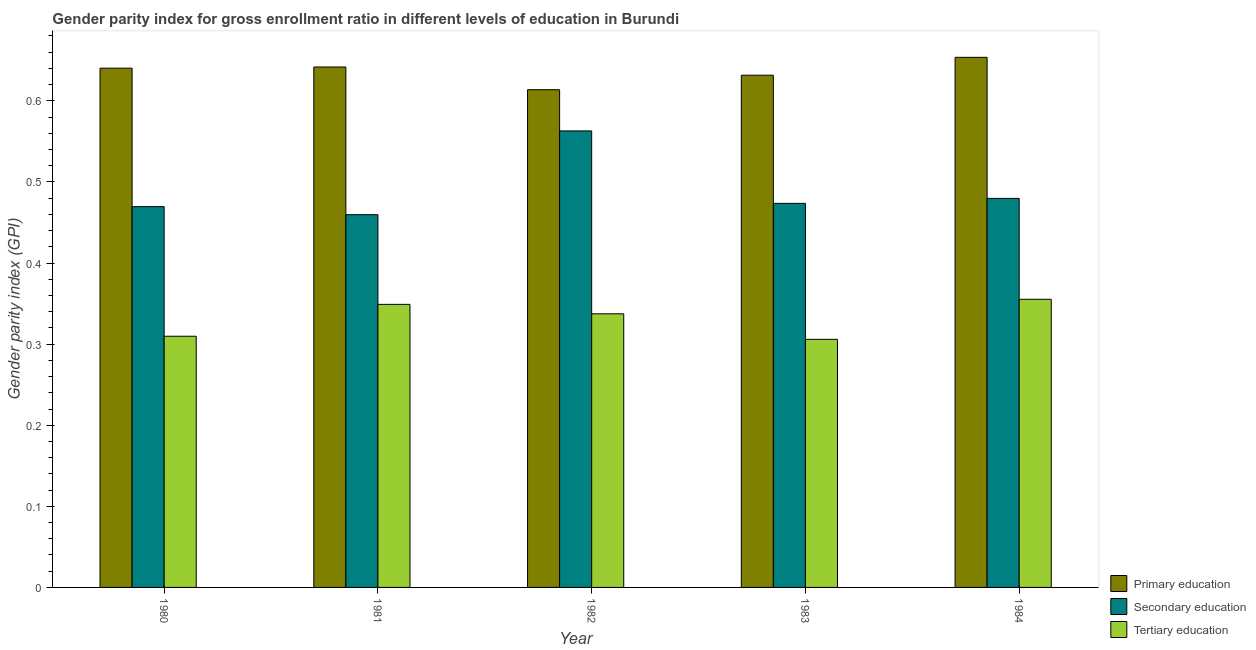How many bars are there on the 3rd tick from the left?
Ensure brevity in your answer.  3. What is the label of the 2nd group of bars from the left?
Offer a terse response. 1981. In how many cases, is the number of bars for a given year not equal to the number of legend labels?
Your response must be concise. 0. What is the gender parity index in tertiary education in 1981?
Your response must be concise. 0.35. Across all years, what is the maximum gender parity index in primary education?
Give a very brief answer. 0.65. Across all years, what is the minimum gender parity index in tertiary education?
Ensure brevity in your answer.  0.31. In which year was the gender parity index in tertiary education minimum?
Offer a very short reply. 1983. What is the total gender parity index in primary education in the graph?
Your answer should be compact. 3.18. What is the difference between the gender parity index in secondary education in 1981 and that in 1982?
Offer a very short reply. -0.1. What is the difference between the gender parity index in secondary education in 1982 and the gender parity index in tertiary education in 1984?
Offer a very short reply. 0.08. What is the average gender parity index in secondary education per year?
Make the answer very short. 0.49. In the year 1984, what is the difference between the gender parity index in primary education and gender parity index in secondary education?
Provide a short and direct response. 0. What is the ratio of the gender parity index in primary education in 1983 to that in 1984?
Make the answer very short. 0.97. Is the gender parity index in secondary education in 1980 less than that in 1982?
Provide a short and direct response. Yes. Is the difference between the gender parity index in tertiary education in 1982 and 1983 greater than the difference between the gender parity index in primary education in 1982 and 1983?
Ensure brevity in your answer.  No. What is the difference between the highest and the second highest gender parity index in tertiary education?
Offer a terse response. 0.01. What is the difference between the highest and the lowest gender parity index in tertiary education?
Ensure brevity in your answer.  0.05. In how many years, is the gender parity index in primary education greater than the average gender parity index in primary education taken over all years?
Your response must be concise. 3. Is the sum of the gender parity index in primary education in 1982 and 1983 greater than the maximum gender parity index in secondary education across all years?
Offer a very short reply. Yes. What does the 2nd bar from the left in 1984 represents?
Ensure brevity in your answer.  Secondary education. What does the 1st bar from the right in 1983 represents?
Your answer should be compact. Tertiary education. How many bars are there?
Give a very brief answer. 15. Are all the bars in the graph horizontal?
Provide a succinct answer. No. How many years are there in the graph?
Offer a very short reply. 5. Does the graph contain any zero values?
Your answer should be very brief. No. Does the graph contain grids?
Offer a very short reply. No. How are the legend labels stacked?
Keep it short and to the point. Vertical. What is the title of the graph?
Offer a terse response. Gender parity index for gross enrollment ratio in different levels of education in Burundi. Does "Interest" appear as one of the legend labels in the graph?
Make the answer very short. No. What is the label or title of the Y-axis?
Your response must be concise. Gender parity index (GPI). What is the Gender parity index (GPI) in Primary education in 1980?
Offer a terse response. 0.64. What is the Gender parity index (GPI) in Secondary education in 1980?
Ensure brevity in your answer.  0.47. What is the Gender parity index (GPI) in Tertiary education in 1980?
Give a very brief answer. 0.31. What is the Gender parity index (GPI) in Primary education in 1981?
Ensure brevity in your answer.  0.64. What is the Gender parity index (GPI) of Secondary education in 1981?
Keep it short and to the point. 0.46. What is the Gender parity index (GPI) in Tertiary education in 1981?
Make the answer very short. 0.35. What is the Gender parity index (GPI) of Primary education in 1982?
Your answer should be compact. 0.61. What is the Gender parity index (GPI) of Secondary education in 1982?
Provide a short and direct response. 0.56. What is the Gender parity index (GPI) in Tertiary education in 1982?
Provide a short and direct response. 0.34. What is the Gender parity index (GPI) of Primary education in 1983?
Your answer should be very brief. 0.63. What is the Gender parity index (GPI) of Secondary education in 1983?
Keep it short and to the point. 0.47. What is the Gender parity index (GPI) of Tertiary education in 1983?
Make the answer very short. 0.31. What is the Gender parity index (GPI) in Primary education in 1984?
Provide a short and direct response. 0.65. What is the Gender parity index (GPI) in Secondary education in 1984?
Provide a short and direct response. 0.48. What is the Gender parity index (GPI) of Tertiary education in 1984?
Your answer should be very brief. 0.36. Across all years, what is the maximum Gender parity index (GPI) of Primary education?
Your response must be concise. 0.65. Across all years, what is the maximum Gender parity index (GPI) of Secondary education?
Your answer should be compact. 0.56. Across all years, what is the maximum Gender parity index (GPI) in Tertiary education?
Make the answer very short. 0.36. Across all years, what is the minimum Gender parity index (GPI) in Primary education?
Ensure brevity in your answer.  0.61. Across all years, what is the minimum Gender parity index (GPI) in Secondary education?
Keep it short and to the point. 0.46. Across all years, what is the minimum Gender parity index (GPI) of Tertiary education?
Give a very brief answer. 0.31. What is the total Gender parity index (GPI) of Primary education in the graph?
Provide a succinct answer. 3.18. What is the total Gender parity index (GPI) in Secondary education in the graph?
Ensure brevity in your answer.  2.45. What is the total Gender parity index (GPI) in Tertiary education in the graph?
Your answer should be very brief. 1.66. What is the difference between the Gender parity index (GPI) in Primary education in 1980 and that in 1981?
Your response must be concise. -0. What is the difference between the Gender parity index (GPI) in Secondary education in 1980 and that in 1981?
Offer a very short reply. 0.01. What is the difference between the Gender parity index (GPI) of Tertiary education in 1980 and that in 1981?
Keep it short and to the point. -0.04. What is the difference between the Gender parity index (GPI) of Primary education in 1980 and that in 1982?
Your answer should be very brief. 0.03. What is the difference between the Gender parity index (GPI) in Secondary education in 1980 and that in 1982?
Keep it short and to the point. -0.09. What is the difference between the Gender parity index (GPI) in Tertiary education in 1980 and that in 1982?
Ensure brevity in your answer.  -0.03. What is the difference between the Gender parity index (GPI) of Primary education in 1980 and that in 1983?
Offer a terse response. 0.01. What is the difference between the Gender parity index (GPI) in Secondary education in 1980 and that in 1983?
Ensure brevity in your answer.  -0. What is the difference between the Gender parity index (GPI) in Tertiary education in 1980 and that in 1983?
Your answer should be very brief. 0. What is the difference between the Gender parity index (GPI) of Primary education in 1980 and that in 1984?
Your response must be concise. -0.01. What is the difference between the Gender parity index (GPI) in Secondary education in 1980 and that in 1984?
Keep it short and to the point. -0.01. What is the difference between the Gender parity index (GPI) in Tertiary education in 1980 and that in 1984?
Your response must be concise. -0.05. What is the difference between the Gender parity index (GPI) in Primary education in 1981 and that in 1982?
Provide a succinct answer. 0.03. What is the difference between the Gender parity index (GPI) in Secondary education in 1981 and that in 1982?
Make the answer very short. -0.1. What is the difference between the Gender parity index (GPI) of Tertiary education in 1981 and that in 1982?
Ensure brevity in your answer.  0.01. What is the difference between the Gender parity index (GPI) in Primary education in 1981 and that in 1983?
Offer a very short reply. 0.01. What is the difference between the Gender parity index (GPI) in Secondary education in 1981 and that in 1983?
Offer a very short reply. -0.01. What is the difference between the Gender parity index (GPI) in Tertiary education in 1981 and that in 1983?
Keep it short and to the point. 0.04. What is the difference between the Gender parity index (GPI) in Primary education in 1981 and that in 1984?
Your answer should be very brief. -0.01. What is the difference between the Gender parity index (GPI) in Secondary education in 1981 and that in 1984?
Ensure brevity in your answer.  -0.02. What is the difference between the Gender parity index (GPI) in Tertiary education in 1981 and that in 1984?
Make the answer very short. -0.01. What is the difference between the Gender parity index (GPI) of Primary education in 1982 and that in 1983?
Your response must be concise. -0.02. What is the difference between the Gender parity index (GPI) of Secondary education in 1982 and that in 1983?
Your answer should be very brief. 0.09. What is the difference between the Gender parity index (GPI) of Tertiary education in 1982 and that in 1983?
Your answer should be very brief. 0.03. What is the difference between the Gender parity index (GPI) of Primary education in 1982 and that in 1984?
Your answer should be very brief. -0.04. What is the difference between the Gender parity index (GPI) of Secondary education in 1982 and that in 1984?
Offer a very short reply. 0.08. What is the difference between the Gender parity index (GPI) of Tertiary education in 1982 and that in 1984?
Your answer should be very brief. -0.02. What is the difference between the Gender parity index (GPI) in Primary education in 1983 and that in 1984?
Make the answer very short. -0.02. What is the difference between the Gender parity index (GPI) in Secondary education in 1983 and that in 1984?
Offer a very short reply. -0.01. What is the difference between the Gender parity index (GPI) of Tertiary education in 1983 and that in 1984?
Your answer should be very brief. -0.05. What is the difference between the Gender parity index (GPI) in Primary education in 1980 and the Gender parity index (GPI) in Secondary education in 1981?
Provide a short and direct response. 0.18. What is the difference between the Gender parity index (GPI) in Primary education in 1980 and the Gender parity index (GPI) in Tertiary education in 1981?
Give a very brief answer. 0.29. What is the difference between the Gender parity index (GPI) in Secondary education in 1980 and the Gender parity index (GPI) in Tertiary education in 1981?
Keep it short and to the point. 0.12. What is the difference between the Gender parity index (GPI) in Primary education in 1980 and the Gender parity index (GPI) in Secondary education in 1982?
Ensure brevity in your answer.  0.08. What is the difference between the Gender parity index (GPI) in Primary education in 1980 and the Gender parity index (GPI) in Tertiary education in 1982?
Provide a succinct answer. 0.3. What is the difference between the Gender parity index (GPI) in Secondary education in 1980 and the Gender parity index (GPI) in Tertiary education in 1982?
Ensure brevity in your answer.  0.13. What is the difference between the Gender parity index (GPI) of Primary education in 1980 and the Gender parity index (GPI) of Secondary education in 1983?
Provide a succinct answer. 0.17. What is the difference between the Gender parity index (GPI) in Primary education in 1980 and the Gender parity index (GPI) in Tertiary education in 1983?
Provide a short and direct response. 0.33. What is the difference between the Gender parity index (GPI) of Secondary education in 1980 and the Gender parity index (GPI) of Tertiary education in 1983?
Your answer should be compact. 0.16. What is the difference between the Gender parity index (GPI) of Primary education in 1980 and the Gender parity index (GPI) of Secondary education in 1984?
Give a very brief answer. 0.16. What is the difference between the Gender parity index (GPI) of Primary education in 1980 and the Gender parity index (GPI) of Tertiary education in 1984?
Provide a succinct answer. 0.28. What is the difference between the Gender parity index (GPI) of Secondary education in 1980 and the Gender parity index (GPI) of Tertiary education in 1984?
Ensure brevity in your answer.  0.11. What is the difference between the Gender parity index (GPI) of Primary education in 1981 and the Gender parity index (GPI) of Secondary education in 1982?
Provide a succinct answer. 0.08. What is the difference between the Gender parity index (GPI) in Primary education in 1981 and the Gender parity index (GPI) in Tertiary education in 1982?
Your response must be concise. 0.3. What is the difference between the Gender parity index (GPI) of Secondary education in 1981 and the Gender parity index (GPI) of Tertiary education in 1982?
Give a very brief answer. 0.12. What is the difference between the Gender parity index (GPI) in Primary education in 1981 and the Gender parity index (GPI) in Secondary education in 1983?
Offer a terse response. 0.17. What is the difference between the Gender parity index (GPI) of Primary education in 1981 and the Gender parity index (GPI) of Tertiary education in 1983?
Ensure brevity in your answer.  0.34. What is the difference between the Gender parity index (GPI) in Secondary education in 1981 and the Gender parity index (GPI) in Tertiary education in 1983?
Ensure brevity in your answer.  0.15. What is the difference between the Gender parity index (GPI) in Primary education in 1981 and the Gender parity index (GPI) in Secondary education in 1984?
Offer a terse response. 0.16. What is the difference between the Gender parity index (GPI) in Primary education in 1981 and the Gender parity index (GPI) in Tertiary education in 1984?
Your answer should be very brief. 0.29. What is the difference between the Gender parity index (GPI) of Secondary education in 1981 and the Gender parity index (GPI) of Tertiary education in 1984?
Provide a short and direct response. 0.1. What is the difference between the Gender parity index (GPI) of Primary education in 1982 and the Gender parity index (GPI) of Secondary education in 1983?
Provide a short and direct response. 0.14. What is the difference between the Gender parity index (GPI) in Primary education in 1982 and the Gender parity index (GPI) in Tertiary education in 1983?
Ensure brevity in your answer.  0.31. What is the difference between the Gender parity index (GPI) of Secondary education in 1982 and the Gender parity index (GPI) of Tertiary education in 1983?
Provide a succinct answer. 0.26. What is the difference between the Gender parity index (GPI) of Primary education in 1982 and the Gender parity index (GPI) of Secondary education in 1984?
Your answer should be compact. 0.13. What is the difference between the Gender parity index (GPI) of Primary education in 1982 and the Gender parity index (GPI) of Tertiary education in 1984?
Offer a terse response. 0.26. What is the difference between the Gender parity index (GPI) in Secondary education in 1982 and the Gender parity index (GPI) in Tertiary education in 1984?
Your answer should be compact. 0.21. What is the difference between the Gender parity index (GPI) of Primary education in 1983 and the Gender parity index (GPI) of Secondary education in 1984?
Your response must be concise. 0.15. What is the difference between the Gender parity index (GPI) in Primary education in 1983 and the Gender parity index (GPI) in Tertiary education in 1984?
Offer a terse response. 0.28. What is the difference between the Gender parity index (GPI) of Secondary education in 1983 and the Gender parity index (GPI) of Tertiary education in 1984?
Give a very brief answer. 0.12. What is the average Gender parity index (GPI) in Primary education per year?
Ensure brevity in your answer.  0.64. What is the average Gender parity index (GPI) in Secondary education per year?
Your answer should be very brief. 0.49. What is the average Gender parity index (GPI) in Tertiary education per year?
Give a very brief answer. 0.33. In the year 1980, what is the difference between the Gender parity index (GPI) of Primary education and Gender parity index (GPI) of Secondary education?
Provide a succinct answer. 0.17. In the year 1980, what is the difference between the Gender parity index (GPI) of Primary education and Gender parity index (GPI) of Tertiary education?
Ensure brevity in your answer.  0.33. In the year 1980, what is the difference between the Gender parity index (GPI) of Secondary education and Gender parity index (GPI) of Tertiary education?
Ensure brevity in your answer.  0.16. In the year 1981, what is the difference between the Gender parity index (GPI) in Primary education and Gender parity index (GPI) in Secondary education?
Give a very brief answer. 0.18. In the year 1981, what is the difference between the Gender parity index (GPI) in Primary education and Gender parity index (GPI) in Tertiary education?
Offer a terse response. 0.29. In the year 1981, what is the difference between the Gender parity index (GPI) in Secondary education and Gender parity index (GPI) in Tertiary education?
Make the answer very short. 0.11. In the year 1982, what is the difference between the Gender parity index (GPI) in Primary education and Gender parity index (GPI) in Secondary education?
Give a very brief answer. 0.05. In the year 1982, what is the difference between the Gender parity index (GPI) of Primary education and Gender parity index (GPI) of Tertiary education?
Your answer should be compact. 0.28. In the year 1982, what is the difference between the Gender parity index (GPI) in Secondary education and Gender parity index (GPI) in Tertiary education?
Keep it short and to the point. 0.23. In the year 1983, what is the difference between the Gender parity index (GPI) in Primary education and Gender parity index (GPI) in Secondary education?
Offer a terse response. 0.16. In the year 1983, what is the difference between the Gender parity index (GPI) of Primary education and Gender parity index (GPI) of Tertiary education?
Offer a terse response. 0.33. In the year 1983, what is the difference between the Gender parity index (GPI) in Secondary education and Gender parity index (GPI) in Tertiary education?
Provide a succinct answer. 0.17. In the year 1984, what is the difference between the Gender parity index (GPI) in Primary education and Gender parity index (GPI) in Secondary education?
Make the answer very short. 0.17. In the year 1984, what is the difference between the Gender parity index (GPI) of Primary education and Gender parity index (GPI) of Tertiary education?
Your response must be concise. 0.3. In the year 1984, what is the difference between the Gender parity index (GPI) in Secondary education and Gender parity index (GPI) in Tertiary education?
Keep it short and to the point. 0.12. What is the ratio of the Gender parity index (GPI) in Secondary education in 1980 to that in 1981?
Your answer should be compact. 1.02. What is the ratio of the Gender parity index (GPI) in Tertiary education in 1980 to that in 1981?
Keep it short and to the point. 0.89. What is the ratio of the Gender parity index (GPI) of Primary education in 1980 to that in 1982?
Offer a very short reply. 1.04. What is the ratio of the Gender parity index (GPI) of Secondary education in 1980 to that in 1982?
Provide a short and direct response. 0.83. What is the ratio of the Gender parity index (GPI) in Tertiary education in 1980 to that in 1982?
Your response must be concise. 0.92. What is the ratio of the Gender parity index (GPI) in Primary education in 1980 to that in 1983?
Give a very brief answer. 1.01. What is the ratio of the Gender parity index (GPI) of Tertiary education in 1980 to that in 1983?
Provide a short and direct response. 1.01. What is the ratio of the Gender parity index (GPI) of Primary education in 1980 to that in 1984?
Your answer should be compact. 0.98. What is the ratio of the Gender parity index (GPI) in Secondary education in 1980 to that in 1984?
Give a very brief answer. 0.98. What is the ratio of the Gender parity index (GPI) in Tertiary education in 1980 to that in 1984?
Provide a short and direct response. 0.87. What is the ratio of the Gender parity index (GPI) in Primary education in 1981 to that in 1982?
Offer a very short reply. 1.05. What is the ratio of the Gender parity index (GPI) of Secondary education in 1981 to that in 1982?
Ensure brevity in your answer.  0.82. What is the ratio of the Gender parity index (GPI) in Tertiary education in 1981 to that in 1982?
Your response must be concise. 1.03. What is the ratio of the Gender parity index (GPI) of Primary education in 1981 to that in 1983?
Provide a short and direct response. 1.02. What is the ratio of the Gender parity index (GPI) in Secondary education in 1981 to that in 1983?
Give a very brief answer. 0.97. What is the ratio of the Gender parity index (GPI) of Tertiary education in 1981 to that in 1983?
Offer a terse response. 1.14. What is the ratio of the Gender parity index (GPI) in Primary education in 1981 to that in 1984?
Offer a terse response. 0.98. What is the ratio of the Gender parity index (GPI) in Secondary education in 1981 to that in 1984?
Keep it short and to the point. 0.96. What is the ratio of the Gender parity index (GPI) of Tertiary education in 1981 to that in 1984?
Make the answer very short. 0.98. What is the ratio of the Gender parity index (GPI) in Primary education in 1982 to that in 1983?
Make the answer very short. 0.97. What is the ratio of the Gender parity index (GPI) in Secondary education in 1982 to that in 1983?
Your response must be concise. 1.19. What is the ratio of the Gender parity index (GPI) of Tertiary education in 1982 to that in 1983?
Give a very brief answer. 1.1. What is the ratio of the Gender parity index (GPI) in Primary education in 1982 to that in 1984?
Give a very brief answer. 0.94. What is the ratio of the Gender parity index (GPI) of Secondary education in 1982 to that in 1984?
Provide a short and direct response. 1.17. What is the ratio of the Gender parity index (GPI) in Tertiary education in 1982 to that in 1984?
Ensure brevity in your answer.  0.95. What is the ratio of the Gender parity index (GPI) in Primary education in 1983 to that in 1984?
Your response must be concise. 0.97. What is the ratio of the Gender parity index (GPI) of Secondary education in 1983 to that in 1984?
Offer a very short reply. 0.99. What is the ratio of the Gender parity index (GPI) of Tertiary education in 1983 to that in 1984?
Provide a succinct answer. 0.86. What is the difference between the highest and the second highest Gender parity index (GPI) in Primary education?
Keep it short and to the point. 0.01. What is the difference between the highest and the second highest Gender parity index (GPI) of Secondary education?
Your answer should be very brief. 0.08. What is the difference between the highest and the second highest Gender parity index (GPI) in Tertiary education?
Ensure brevity in your answer.  0.01. What is the difference between the highest and the lowest Gender parity index (GPI) in Primary education?
Keep it short and to the point. 0.04. What is the difference between the highest and the lowest Gender parity index (GPI) in Secondary education?
Keep it short and to the point. 0.1. What is the difference between the highest and the lowest Gender parity index (GPI) of Tertiary education?
Provide a short and direct response. 0.05. 